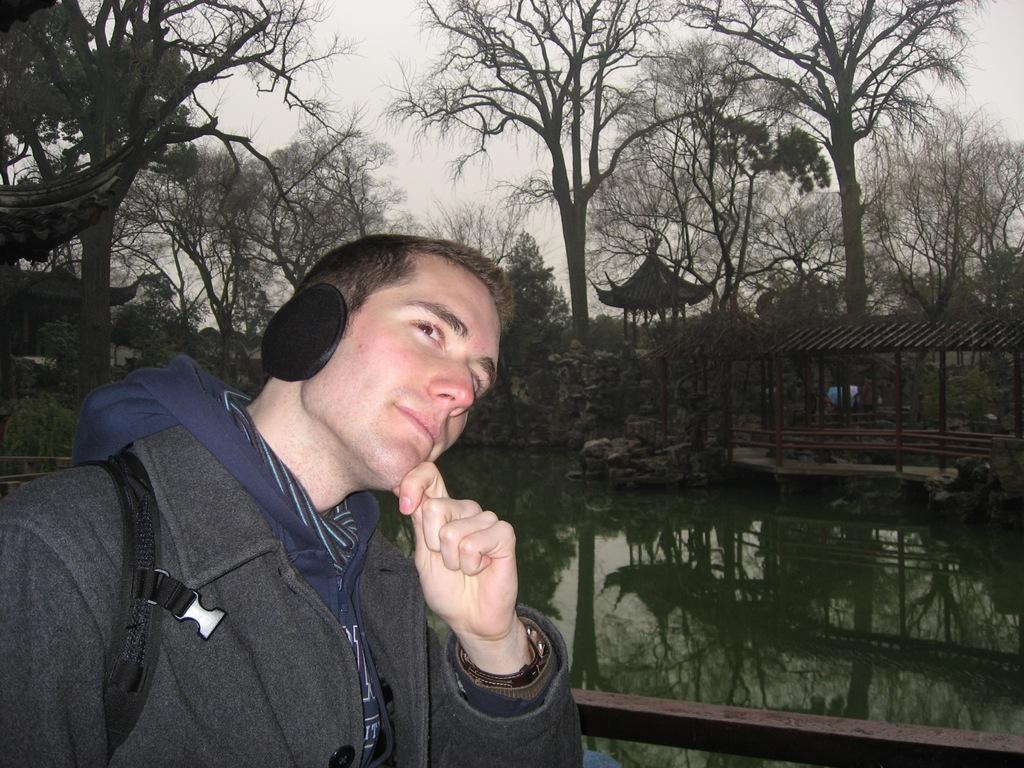What is the main subject of the image? There is a person in the image. What type of clothing is the person wearing? The person is wearing a jacket, a watch, and an ear warmer. What can be seen in the background of the image? The sky is visible in the background of the image. What type of structures are present in the image? There are wooden sheds in the image. What natural elements can be seen in the image? There is water and trees visible in the image. What type of marble is being used to decorate the shoe in the image? There is no shoe or marble present in the image. What type of gate can be seen in the image? There is no gate present in the image. 